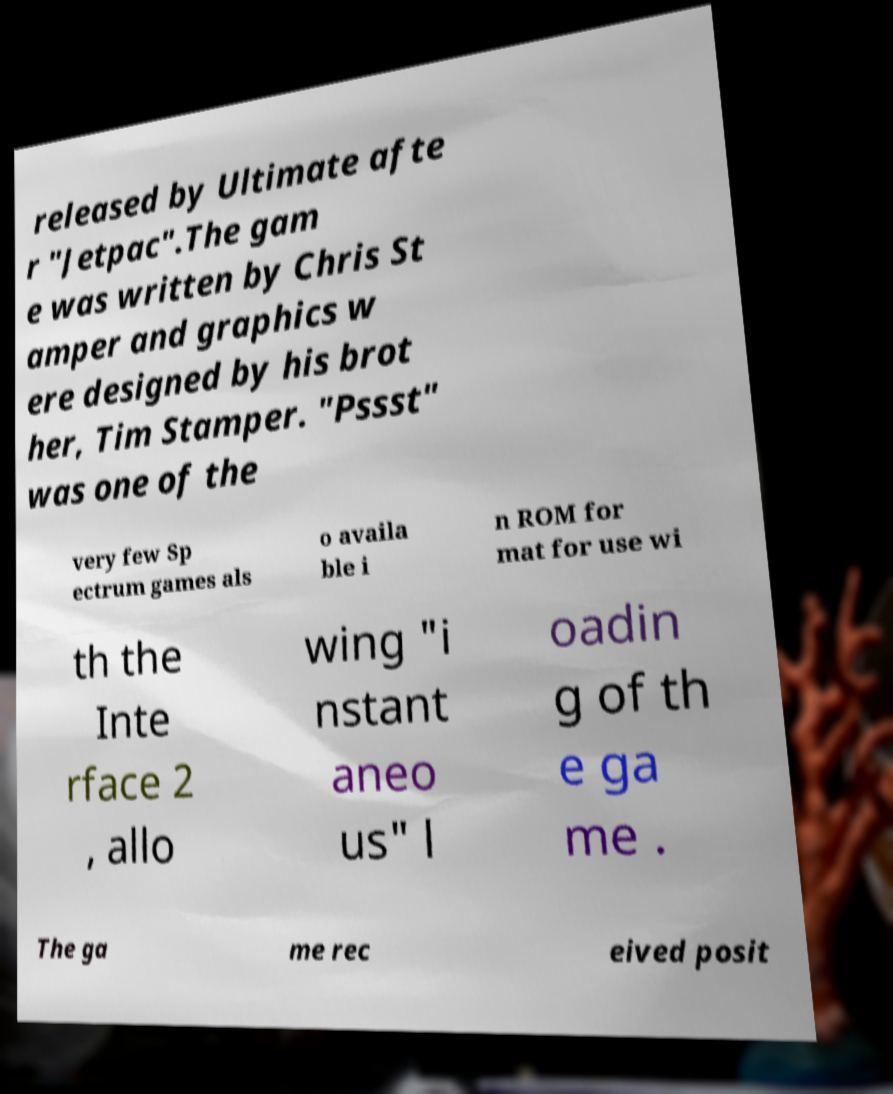Please read and relay the text visible in this image. What does it say? released by Ultimate afte r "Jetpac".The gam e was written by Chris St amper and graphics w ere designed by his brot her, Tim Stamper. "Pssst" was one of the very few Sp ectrum games als o availa ble i n ROM for mat for use wi th the Inte rface 2 , allo wing "i nstant aneo us" l oadin g of th e ga me . The ga me rec eived posit 